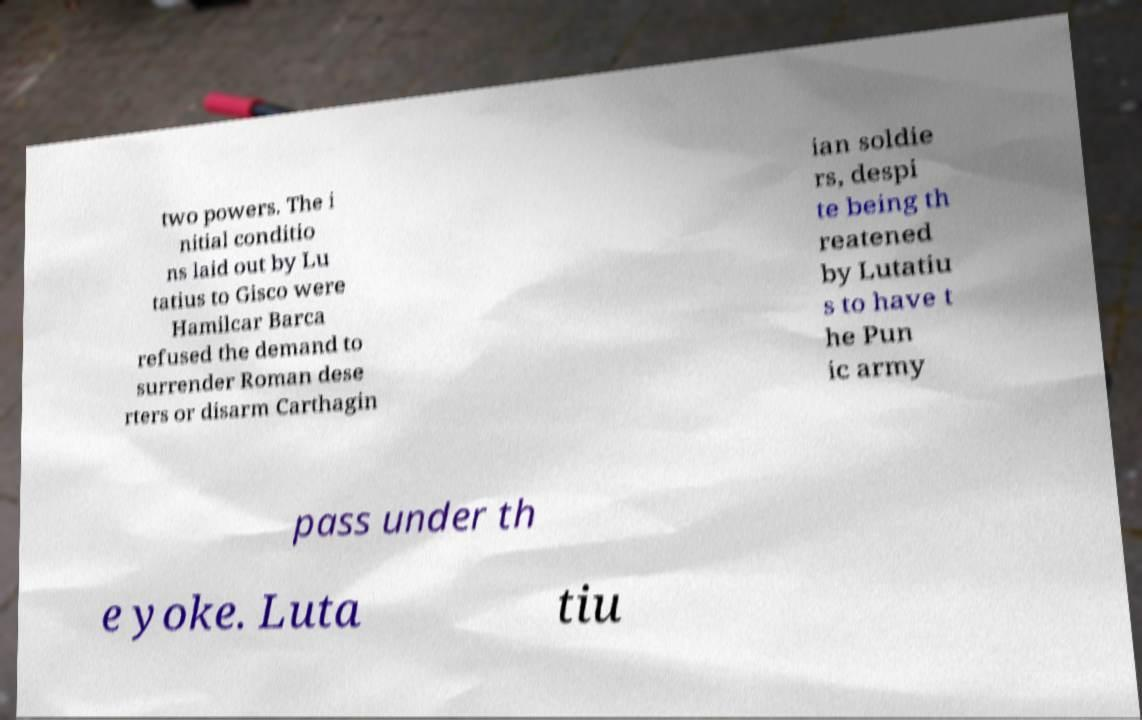Can you read and provide the text displayed in the image?This photo seems to have some interesting text. Can you extract and type it out for me? two powers. The i nitial conditio ns laid out by Lu tatius to Gisco were Hamilcar Barca refused the demand to surrender Roman dese rters or disarm Carthagin ian soldie rs, despi te being th reatened by Lutatiu s to have t he Pun ic army pass under th e yoke. Luta tiu 